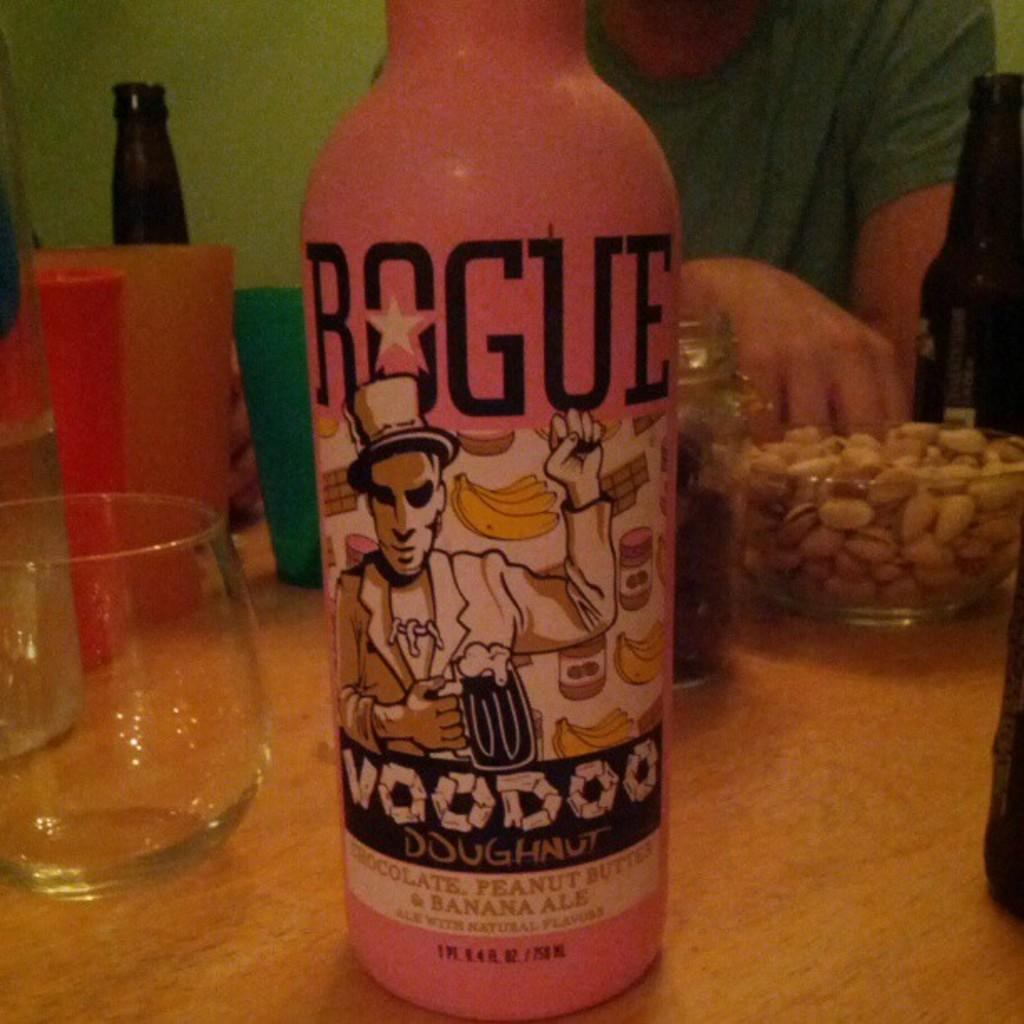<image>
Give a short and clear explanation of the subsequent image. A bottle of Rogue Voodoo beer on a table 